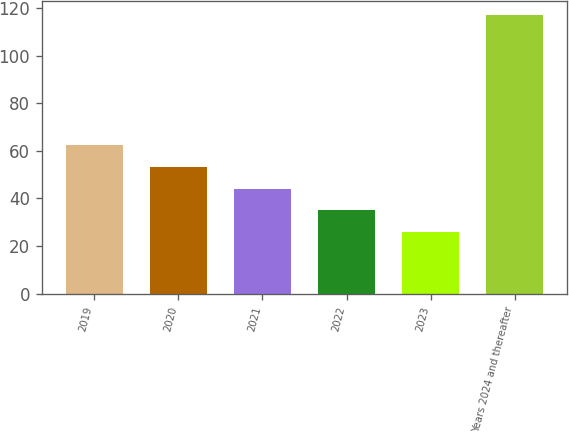Convert chart to OTSL. <chart><loc_0><loc_0><loc_500><loc_500><bar_chart><fcel>2019<fcel>2020<fcel>2021<fcel>2022<fcel>2023<fcel>Years 2024 and thereafter<nl><fcel>62.36<fcel>53.22<fcel>44.08<fcel>34.94<fcel>25.8<fcel>117.2<nl></chart> 